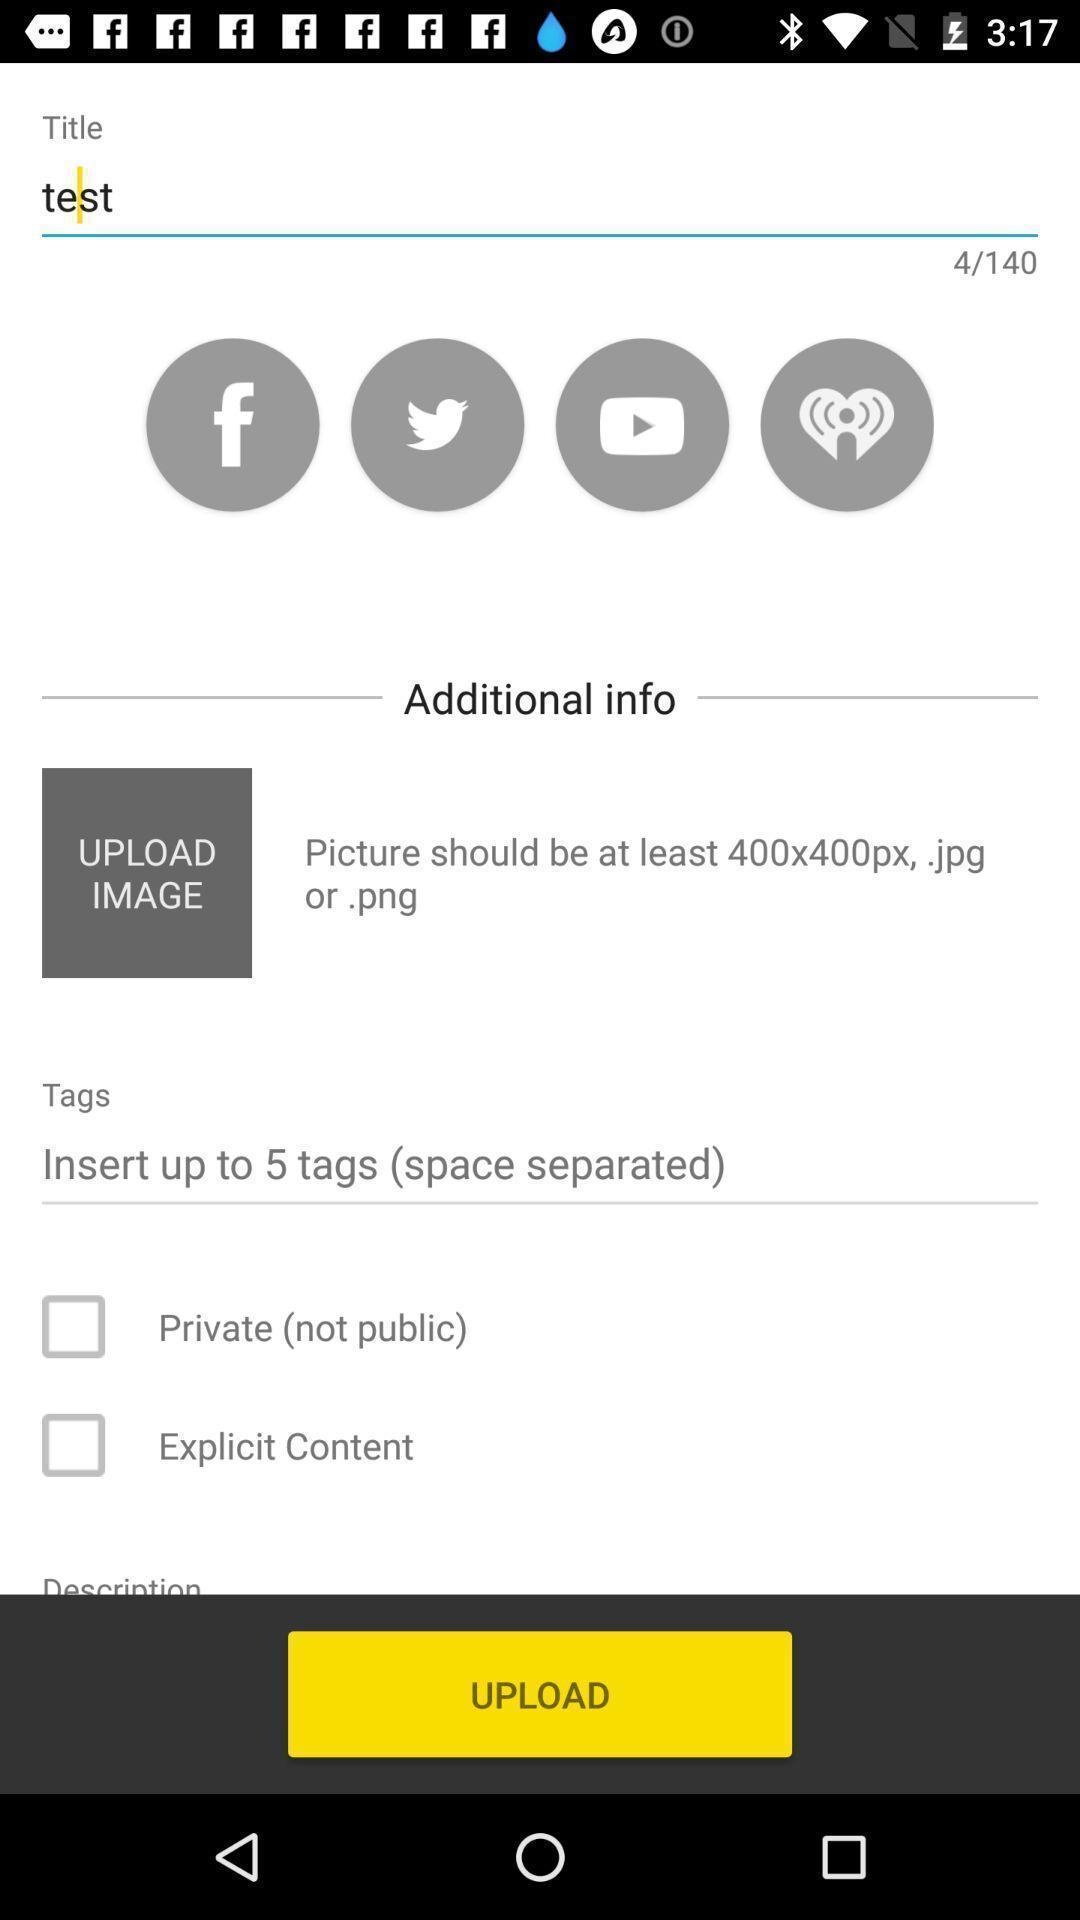Describe this image in words. Screen showing additional info with upload option. 